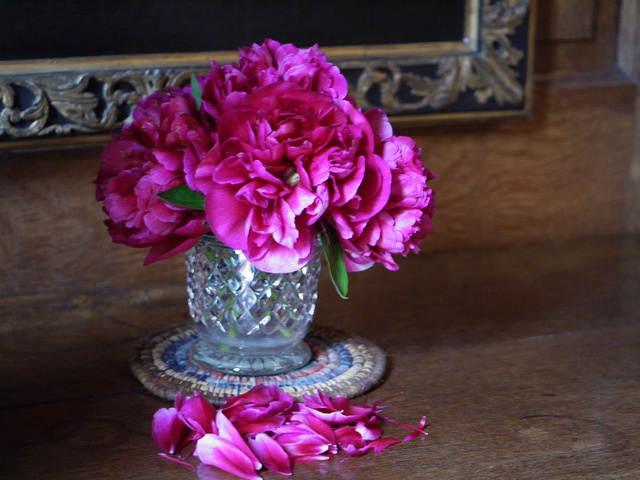Describe the objects in this image and their specific colors. I can see a vase in black, gray, and darkgray tones in this image. 